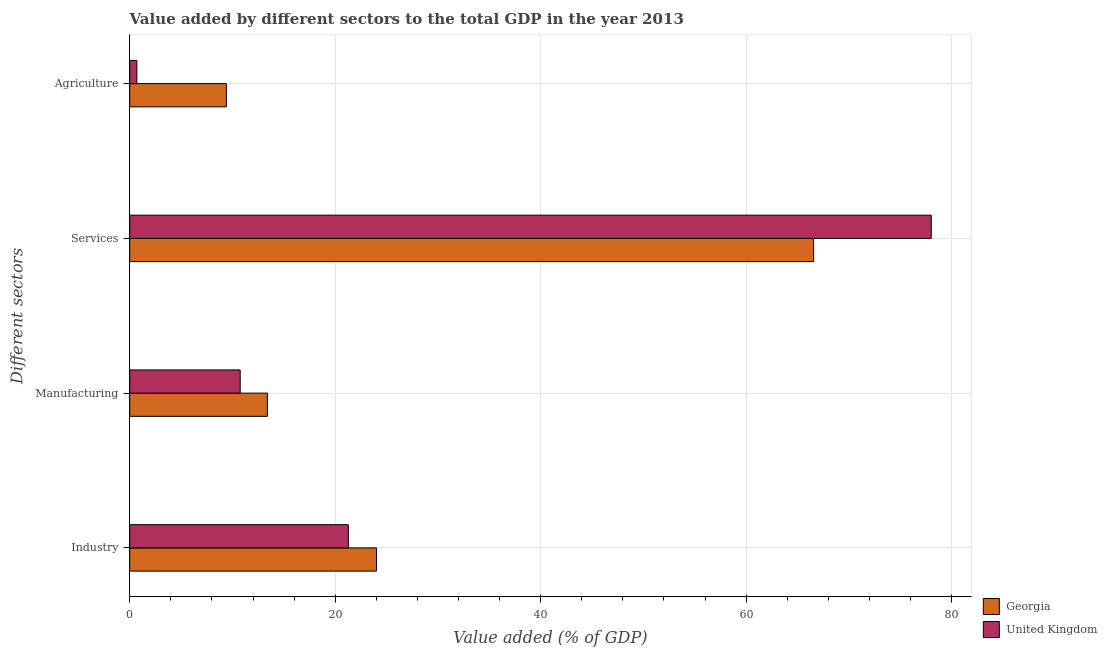How many different coloured bars are there?
Offer a very short reply. 2. How many groups of bars are there?
Offer a terse response. 4. Are the number of bars per tick equal to the number of legend labels?
Your answer should be very brief. Yes. How many bars are there on the 2nd tick from the top?
Keep it short and to the point. 2. What is the label of the 2nd group of bars from the top?
Keep it short and to the point. Services. What is the value added by services sector in Georgia?
Offer a terse response. 66.57. Across all countries, what is the maximum value added by manufacturing sector?
Provide a succinct answer. 13.4. Across all countries, what is the minimum value added by services sector?
Make the answer very short. 66.57. In which country was the value added by services sector maximum?
Ensure brevity in your answer.  United Kingdom. In which country was the value added by agricultural sector minimum?
Offer a very short reply. United Kingdom. What is the total value added by services sector in the graph?
Make the answer very short. 144.6. What is the difference between the value added by services sector in Georgia and that in United Kingdom?
Provide a succinct answer. -11.45. What is the difference between the value added by industrial sector in United Kingdom and the value added by services sector in Georgia?
Offer a very short reply. -45.29. What is the average value added by agricultural sector per country?
Ensure brevity in your answer.  5.05. What is the difference between the value added by agricultural sector and value added by manufacturing sector in Georgia?
Keep it short and to the point. -3.99. In how many countries, is the value added by industrial sector greater than 32 %?
Provide a succinct answer. 0. What is the ratio of the value added by services sector in United Kingdom to that in Georgia?
Offer a very short reply. 1.17. Is the difference between the value added by manufacturing sector in United Kingdom and Georgia greater than the difference between the value added by industrial sector in United Kingdom and Georgia?
Your answer should be compact. Yes. What is the difference between the highest and the second highest value added by industrial sector?
Your answer should be very brief. 2.74. What is the difference between the highest and the lowest value added by industrial sector?
Provide a short and direct response. 2.74. In how many countries, is the value added by agricultural sector greater than the average value added by agricultural sector taken over all countries?
Offer a very short reply. 1. Is the sum of the value added by services sector in Georgia and United Kingdom greater than the maximum value added by manufacturing sector across all countries?
Your answer should be very brief. Yes. Is it the case that in every country, the sum of the value added by agricultural sector and value added by manufacturing sector is greater than the sum of value added by services sector and value added by industrial sector?
Ensure brevity in your answer.  No. What does the 2nd bar from the top in Industry represents?
Give a very brief answer. Georgia. What does the 2nd bar from the bottom in Manufacturing represents?
Offer a very short reply. United Kingdom. Is it the case that in every country, the sum of the value added by industrial sector and value added by manufacturing sector is greater than the value added by services sector?
Give a very brief answer. No. What is the difference between two consecutive major ticks on the X-axis?
Offer a very short reply. 20. Are the values on the major ticks of X-axis written in scientific E-notation?
Your answer should be very brief. No. Does the graph contain any zero values?
Your response must be concise. No. Does the graph contain grids?
Give a very brief answer. Yes. Where does the legend appear in the graph?
Your response must be concise. Bottom right. How are the legend labels stacked?
Offer a very short reply. Vertical. What is the title of the graph?
Offer a very short reply. Value added by different sectors to the total GDP in the year 2013. Does "Brazil" appear as one of the legend labels in the graph?
Provide a short and direct response. No. What is the label or title of the X-axis?
Your response must be concise. Value added (% of GDP). What is the label or title of the Y-axis?
Make the answer very short. Different sectors. What is the Value added (% of GDP) in Georgia in Industry?
Your response must be concise. 24.02. What is the Value added (% of GDP) in United Kingdom in Industry?
Keep it short and to the point. 21.28. What is the Value added (% of GDP) of Georgia in Manufacturing?
Your answer should be compact. 13.4. What is the Value added (% of GDP) in United Kingdom in Manufacturing?
Provide a succinct answer. 10.75. What is the Value added (% of GDP) of Georgia in Services?
Your answer should be very brief. 66.57. What is the Value added (% of GDP) in United Kingdom in Services?
Provide a succinct answer. 78.02. What is the Value added (% of GDP) of Georgia in Agriculture?
Offer a very short reply. 9.41. What is the Value added (% of GDP) of United Kingdom in Agriculture?
Ensure brevity in your answer.  0.69. Across all Different sectors, what is the maximum Value added (% of GDP) in Georgia?
Your answer should be compact. 66.57. Across all Different sectors, what is the maximum Value added (% of GDP) in United Kingdom?
Your answer should be compact. 78.02. Across all Different sectors, what is the minimum Value added (% of GDP) of Georgia?
Ensure brevity in your answer.  9.41. Across all Different sectors, what is the minimum Value added (% of GDP) in United Kingdom?
Give a very brief answer. 0.69. What is the total Value added (% of GDP) in Georgia in the graph?
Ensure brevity in your answer.  113.4. What is the total Value added (% of GDP) in United Kingdom in the graph?
Offer a terse response. 110.75. What is the difference between the Value added (% of GDP) in Georgia in Industry and that in Manufacturing?
Offer a terse response. 10.62. What is the difference between the Value added (% of GDP) of United Kingdom in Industry and that in Manufacturing?
Your answer should be compact. 10.53. What is the difference between the Value added (% of GDP) in Georgia in Industry and that in Services?
Offer a very short reply. -42.55. What is the difference between the Value added (% of GDP) of United Kingdom in Industry and that in Services?
Provide a succinct answer. -56.74. What is the difference between the Value added (% of GDP) in Georgia in Industry and that in Agriculture?
Ensure brevity in your answer.  14.61. What is the difference between the Value added (% of GDP) of United Kingdom in Industry and that in Agriculture?
Your answer should be very brief. 20.59. What is the difference between the Value added (% of GDP) in Georgia in Manufacturing and that in Services?
Offer a terse response. -53.17. What is the difference between the Value added (% of GDP) of United Kingdom in Manufacturing and that in Services?
Give a very brief answer. -67.27. What is the difference between the Value added (% of GDP) in Georgia in Manufacturing and that in Agriculture?
Offer a very short reply. 3.99. What is the difference between the Value added (% of GDP) in United Kingdom in Manufacturing and that in Agriculture?
Provide a succinct answer. 10.06. What is the difference between the Value added (% of GDP) of Georgia in Services and that in Agriculture?
Your answer should be very brief. 57.17. What is the difference between the Value added (% of GDP) in United Kingdom in Services and that in Agriculture?
Ensure brevity in your answer.  77.33. What is the difference between the Value added (% of GDP) of Georgia in Industry and the Value added (% of GDP) of United Kingdom in Manufacturing?
Ensure brevity in your answer.  13.27. What is the difference between the Value added (% of GDP) of Georgia in Industry and the Value added (% of GDP) of United Kingdom in Services?
Offer a terse response. -54. What is the difference between the Value added (% of GDP) in Georgia in Industry and the Value added (% of GDP) in United Kingdom in Agriculture?
Give a very brief answer. 23.33. What is the difference between the Value added (% of GDP) of Georgia in Manufacturing and the Value added (% of GDP) of United Kingdom in Services?
Provide a short and direct response. -64.62. What is the difference between the Value added (% of GDP) in Georgia in Manufacturing and the Value added (% of GDP) in United Kingdom in Agriculture?
Your response must be concise. 12.71. What is the difference between the Value added (% of GDP) of Georgia in Services and the Value added (% of GDP) of United Kingdom in Agriculture?
Keep it short and to the point. 65.88. What is the average Value added (% of GDP) of Georgia per Different sectors?
Ensure brevity in your answer.  28.35. What is the average Value added (% of GDP) in United Kingdom per Different sectors?
Provide a short and direct response. 27.69. What is the difference between the Value added (% of GDP) of Georgia and Value added (% of GDP) of United Kingdom in Industry?
Your answer should be compact. 2.74. What is the difference between the Value added (% of GDP) of Georgia and Value added (% of GDP) of United Kingdom in Manufacturing?
Your response must be concise. 2.65. What is the difference between the Value added (% of GDP) of Georgia and Value added (% of GDP) of United Kingdom in Services?
Offer a very short reply. -11.45. What is the difference between the Value added (% of GDP) in Georgia and Value added (% of GDP) in United Kingdom in Agriculture?
Offer a terse response. 8.71. What is the ratio of the Value added (% of GDP) in Georgia in Industry to that in Manufacturing?
Offer a very short reply. 1.79. What is the ratio of the Value added (% of GDP) of United Kingdom in Industry to that in Manufacturing?
Offer a very short reply. 1.98. What is the ratio of the Value added (% of GDP) of Georgia in Industry to that in Services?
Provide a succinct answer. 0.36. What is the ratio of the Value added (% of GDP) of United Kingdom in Industry to that in Services?
Keep it short and to the point. 0.27. What is the ratio of the Value added (% of GDP) in Georgia in Industry to that in Agriculture?
Your answer should be compact. 2.55. What is the ratio of the Value added (% of GDP) of United Kingdom in Industry to that in Agriculture?
Make the answer very short. 30.67. What is the ratio of the Value added (% of GDP) in Georgia in Manufacturing to that in Services?
Give a very brief answer. 0.2. What is the ratio of the Value added (% of GDP) of United Kingdom in Manufacturing to that in Services?
Offer a terse response. 0.14. What is the ratio of the Value added (% of GDP) in Georgia in Manufacturing to that in Agriculture?
Ensure brevity in your answer.  1.42. What is the ratio of the Value added (% of GDP) in United Kingdom in Manufacturing to that in Agriculture?
Make the answer very short. 15.5. What is the ratio of the Value added (% of GDP) of Georgia in Services to that in Agriculture?
Make the answer very short. 7.08. What is the ratio of the Value added (% of GDP) in United Kingdom in Services to that in Agriculture?
Offer a very short reply. 112.44. What is the difference between the highest and the second highest Value added (% of GDP) in Georgia?
Keep it short and to the point. 42.55. What is the difference between the highest and the second highest Value added (% of GDP) of United Kingdom?
Provide a succinct answer. 56.74. What is the difference between the highest and the lowest Value added (% of GDP) in Georgia?
Ensure brevity in your answer.  57.17. What is the difference between the highest and the lowest Value added (% of GDP) of United Kingdom?
Provide a short and direct response. 77.33. 